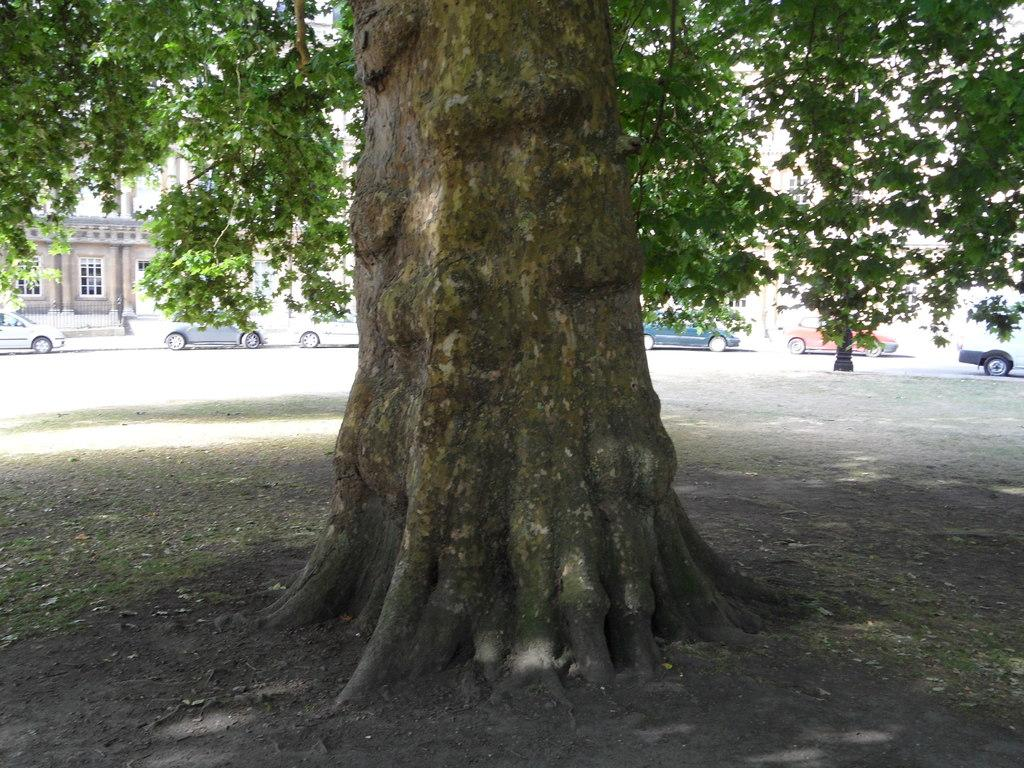What is the main subject in the middle of the picture? There is a tree in the middle of the picture. What is happening in the background of the image? There are cars moving in the background of the image. What type of structures can be seen in the background? There are buildings visible in the background of the image. What type of stomach pain is the tree experiencing in the image? Trees do not experience stomach pain, as they are not living organisms with a digestive system. 